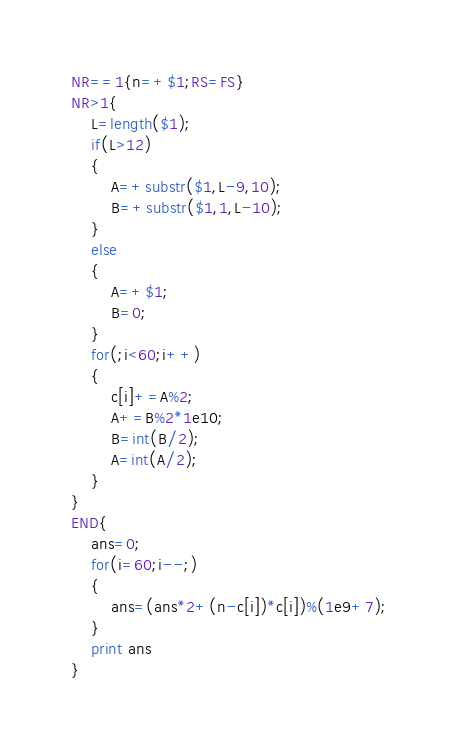Convert code to text. <code><loc_0><loc_0><loc_500><loc_500><_Awk_>NR==1{n=+$1;RS=FS}
NR>1{
	L=length($1);
	if(L>12)
	{
		A=+substr($1,L-9,10);
		B=+substr($1,1,L-10);
	}
	else
	{
		A=+$1;
		B=0;
	}
	for(;i<60;i++)
	{
		c[i]+=A%2;
		A+=B%2*1e10;
		B=int(B/2);
		A=int(A/2);
	}
}
END{
	ans=0;
	for(i=60;i--;)
	{
		ans=(ans*2+(n-c[i])*c[i])%(1e9+7);
	}
	print ans
}</code> 